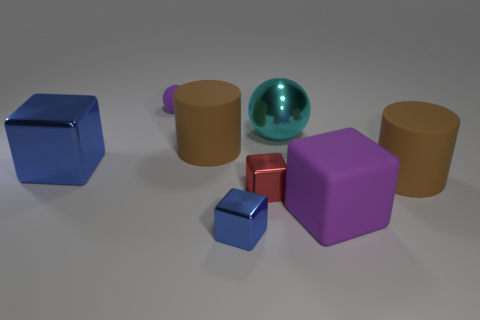Are the large blue thing and the purple thing on the right side of the purple matte ball made of the same material?
Keep it short and to the point. No. Is the number of objects in front of the big metallic cube less than the number of red objects to the right of the big purple matte block?
Ensure brevity in your answer.  No. What number of balls are made of the same material as the red cube?
Keep it short and to the point. 1. There is a large matte thing that is to the left of the small shiny block in front of the large purple object; is there a big matte thing right of it?
Your answer should be very brief. Yes. What number of cubes are tiny purple rubber things or brown things?
Keep it short and to the point. 0. There is a tiny purple matte thing; is it the same shape as the big metal thing on the left side of the small red object?
Give a very brief answer. No. Are there fewer cyan metal spheres that are on the left side of the tiny matte thing than metallic objects?
Make the answer very short. Yes. Are there any blue cubes on the left side of the cyan metallic object?
Your response must be concise. Yes. Is there another matte thing that has the same shape as the small rubber object?
Make the answer very short. No. What shape is the purple matte object that is the same size as the red cube?
Offer a very short reply. Sphere. 